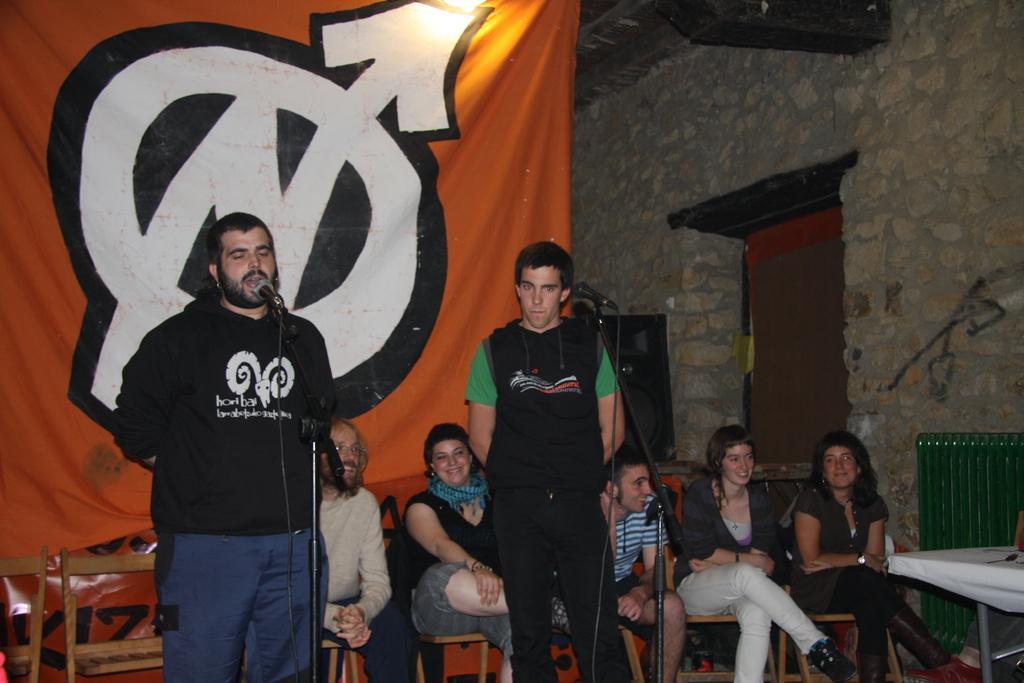Please provide a concise description of this image. 2 men are standing wearing black t shirts. There are microphones in front of them. People are seated on the chairs at the back. There is an orange banner behind them. There is a stone wall and a speaker on the right. 